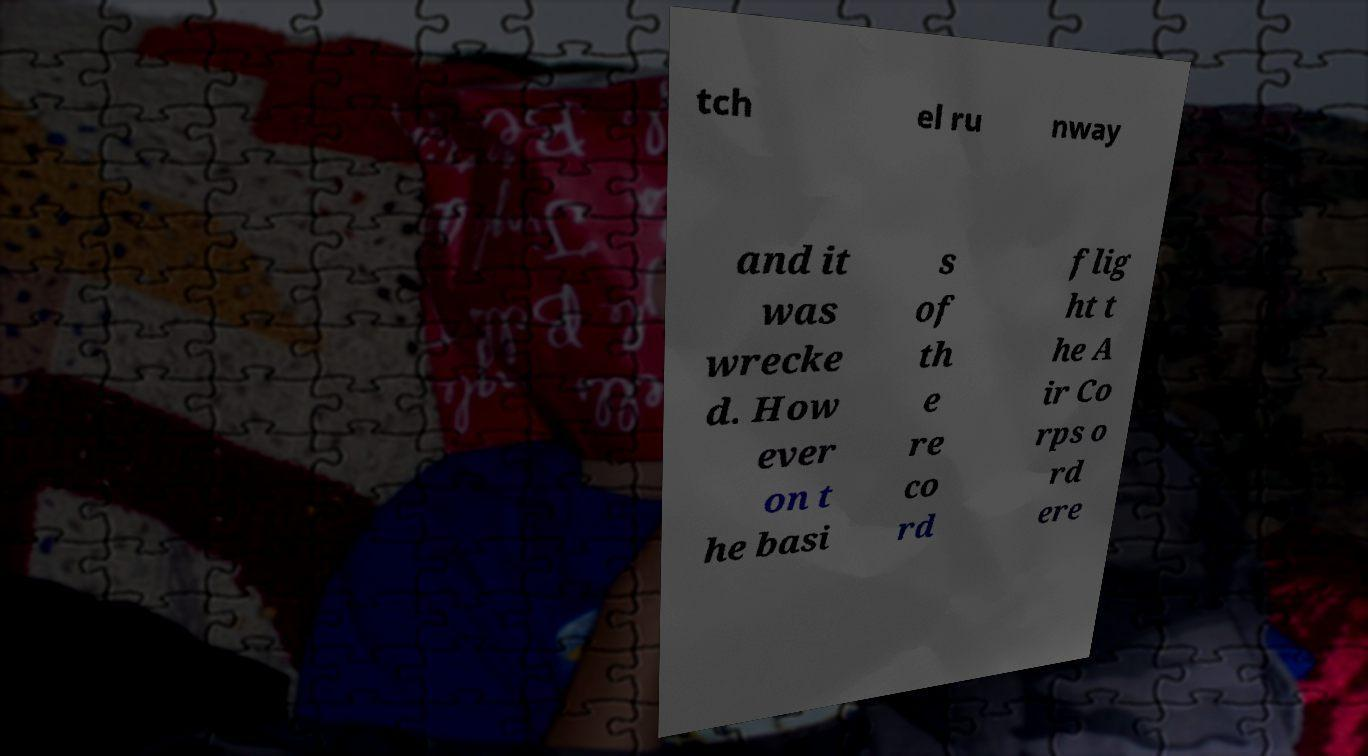Please read and relay the text visible in this image. What does it say? tch el ru nway and it was wrecke d. How ever on t he basi s of th e re co rd flig ht t he A ir Co rps o rd ere 